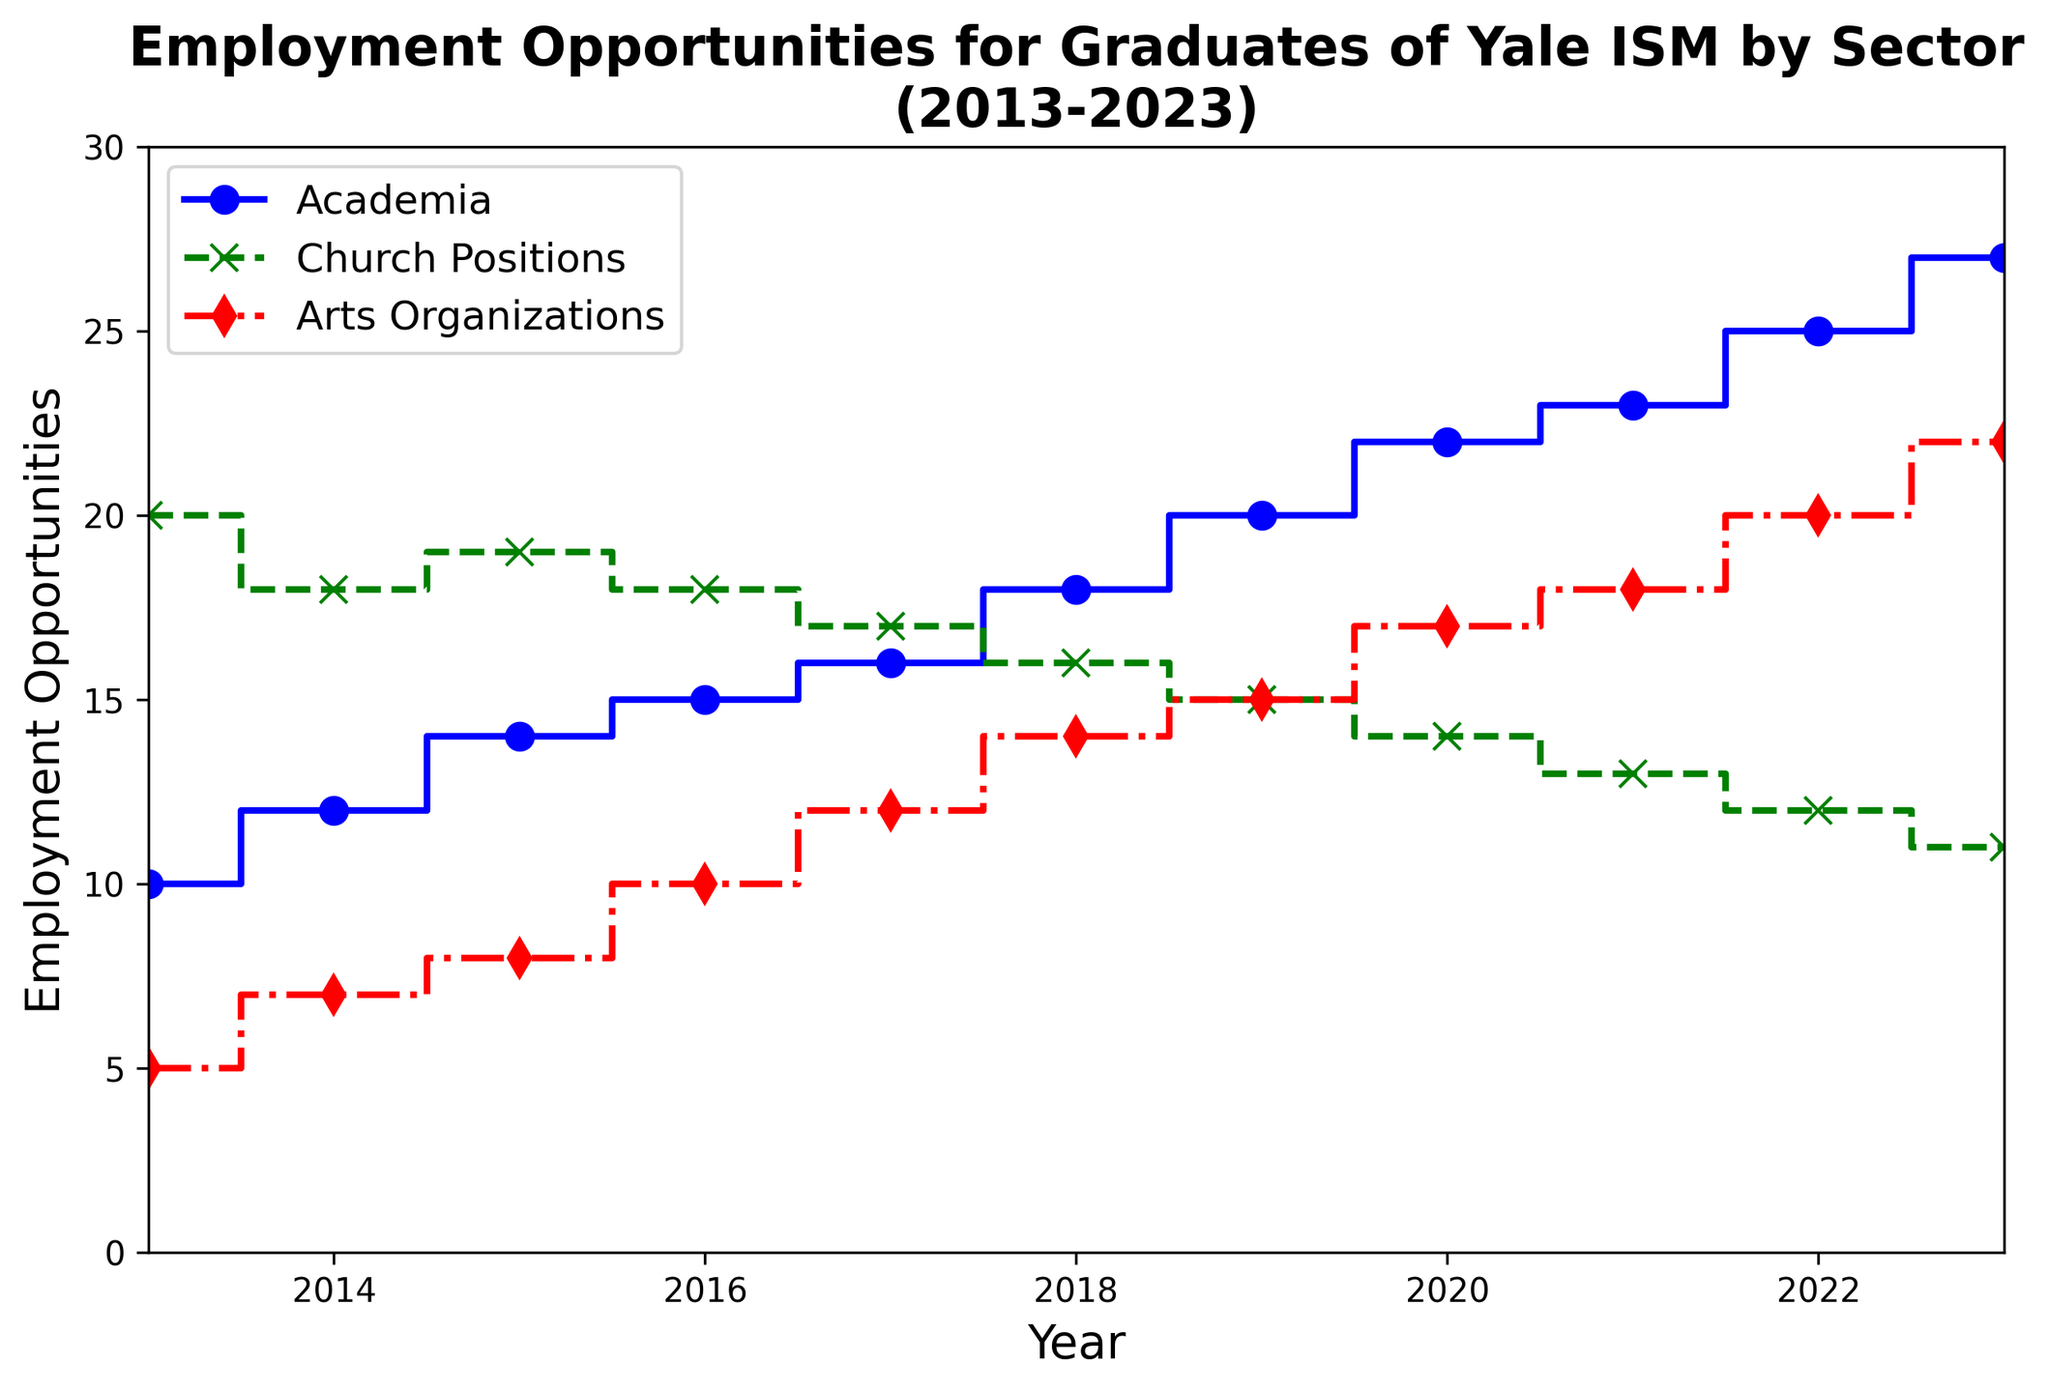What's the highest number of employment opportunities for Academia? The figure shows a stairs plot with "Academia" represented by a blue line. The highest point on this line is 27 in 2023.
Answer: 27 What sector had the most employment opportunities in 2017? In 2017, the figure indicates the following opportunities: Academia (16), Church Positions (17), and Arts Organizations (12). Church Positions had the highest number.
Answer: Church Positions How many more employment opportunities were there in Academia compared to Church Positions in 2020? In 2020, Academia had 22 opportunities, while Church Positions had 14. The difference is 22 - 14 = 8.
Answer: 8 In which year did Arts Organizations see the same number of opportunities as Church Positions had in 2019? Church Positions had 15 opportunities in 2019. From the plot, we see that Arts Organizations reached 15 in 2019.
Answer: 2019 What's the average annual increase in employment opportunities for Academia from 2013 to 2023? Over 10 years (2023-2013), Academia increased from 10 to 27. The average annual increase is (27 - 10) / 10 = 1.7.
Answer: 1.7 Which sector shows the most consistent decline in employment opportunities from 2013 to 2023? The green line representing Church Positions consistently decreases from 20 in 2013 to 11 in 2023.
Answer: Church Positions How many total employment opportunities were there across all sectors in 2018? In 2018, Academia had 18, Church Positions had 16, and Arts Organizations had 14. Total = 18 + 16 + 14 = 48.
Answer: 48 Did the number of employment opportunities for Arts Organizations surpass Church Positions at any point between 2013 and 2023? Yes, starting in 2020, Arts Organizations surpass Church Positions, continuing through 2023.
Answer: Yes What was the employment trend for Arts Organizations from 2013 to 2023? The red line shows an upward trend for Arts Organizations, increasing from 5 in 2013 to 22 in 2023.
Answer: Upward trend By how much did the total number of employment opportunities in all sectors increase from 2013 to 2023? In 2013, total opportunities = 10 + 20 + 5 = 35. In 2023, total = 27 + 11 + 22 = 60. The increase = 60 - 35 = 25.
Answer: 25 